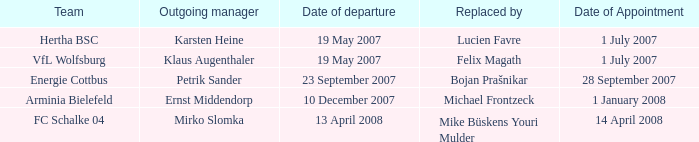When was the appointment date for VFL Wolfsburg? 1 July 2007. 